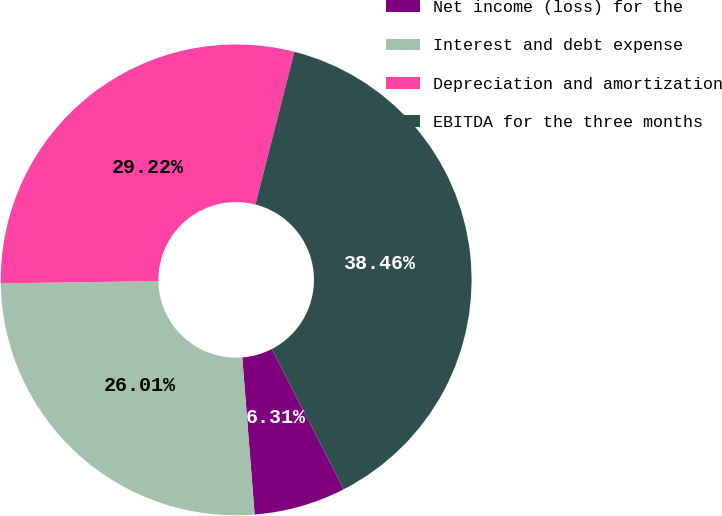Convert chart to OTSL. <chart><loc_0><loc_0><loc_500><loc_500><pie_chart><fcel>Net income (loss) for the<fcel>Interest and debt expense<fcel>Depreciation and amortization<fcel>EBITDA for the three months<nl><fcel>6.31%<fcel>26.01%<fcel>29.22%<fcel>38.46%<nl></chart> 